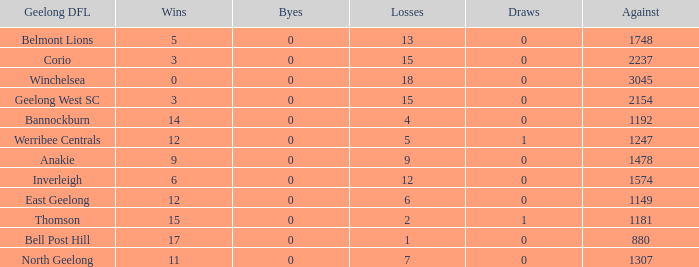What are the average losses for Geelong DFL of Bell Post Hill where the draws are less than 0? None. 